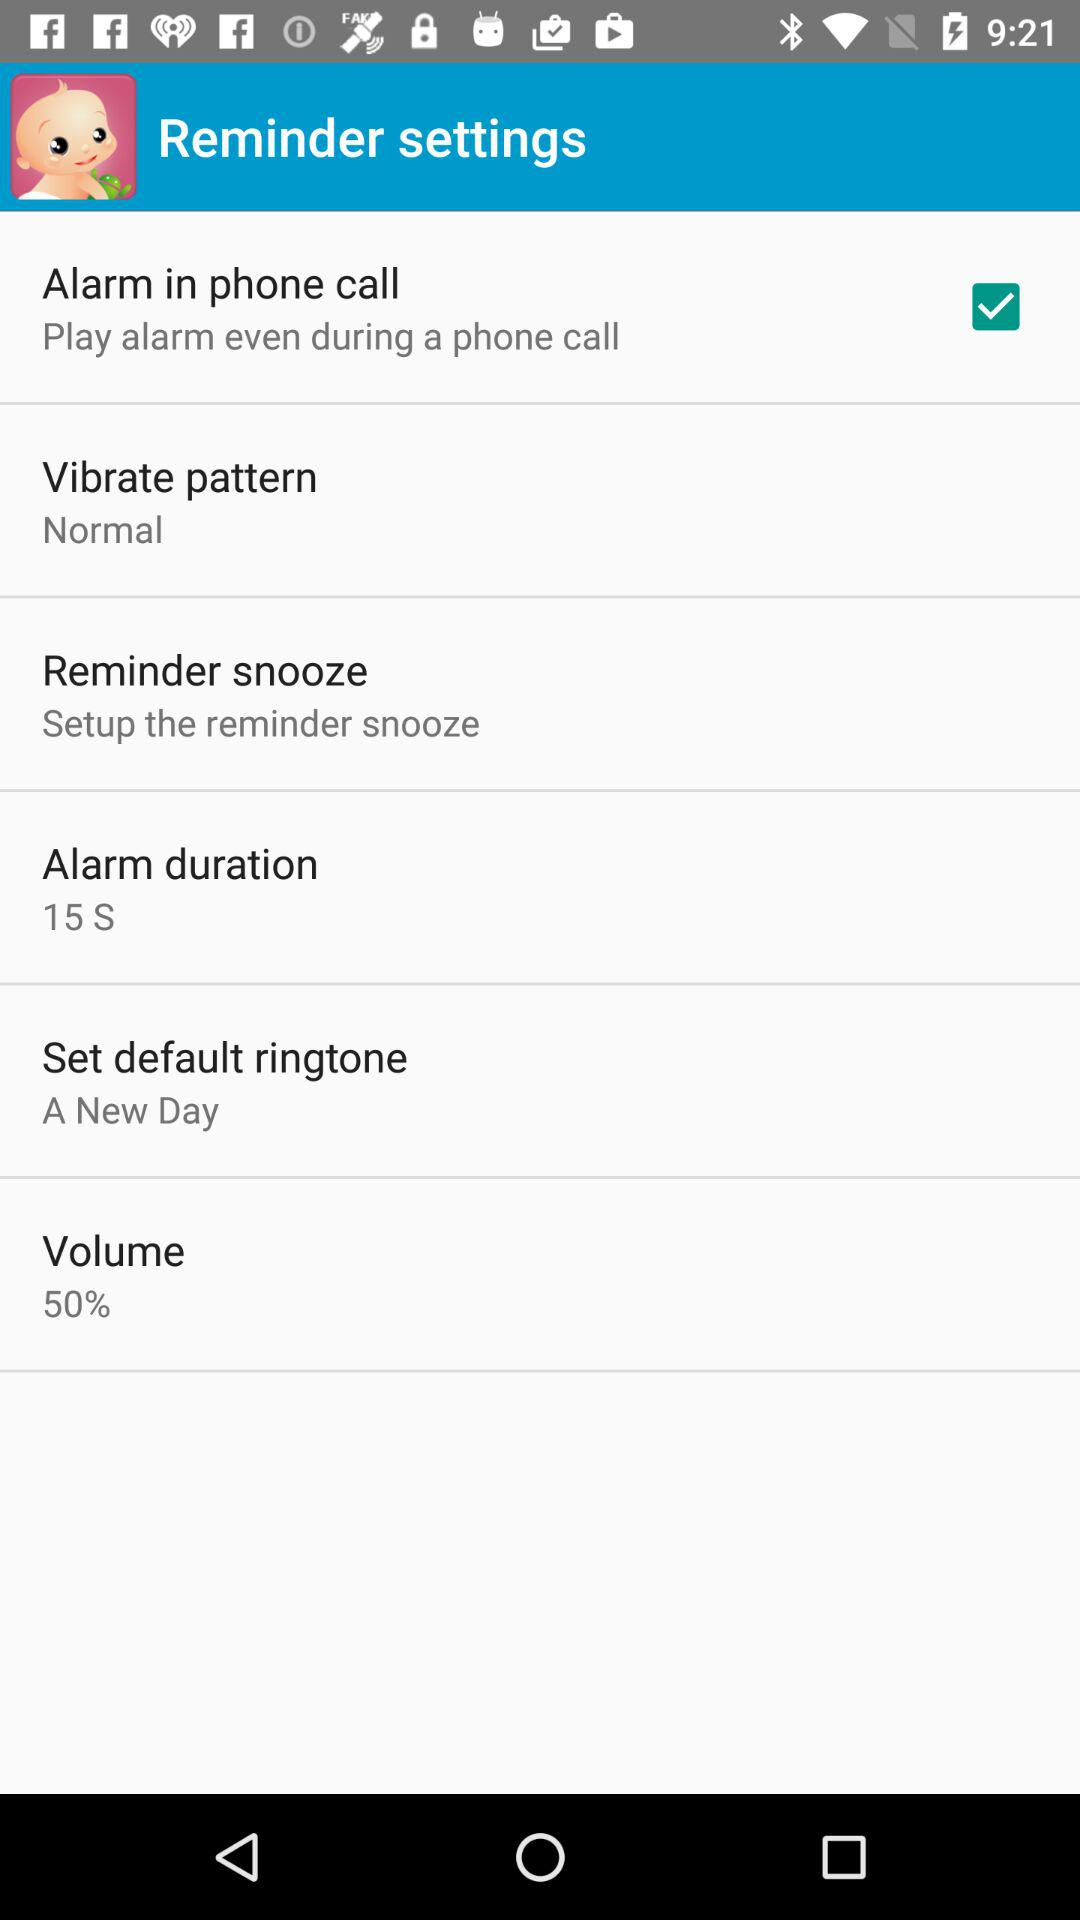What is the ringtone that comes with phone by default?
When the provided information is insufficient, respond with <no answer>. <no answer> 